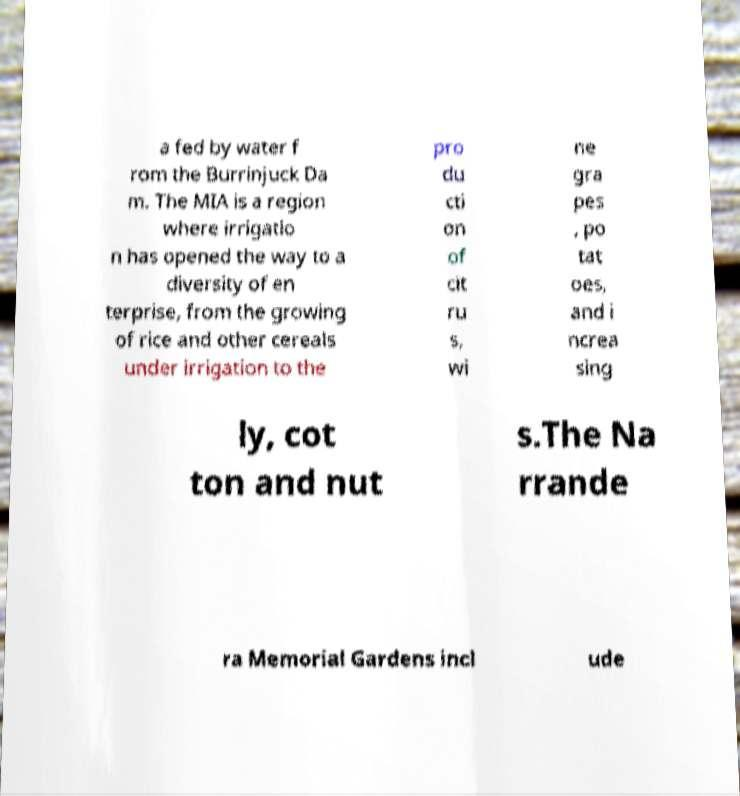For documentation purposes, I need the text within this image transcribed. Could you provide that? a fed by water f rom the Burrinjuck Da m. The MIA is a region where irrigatio n has opened the way to a diversity of en terprise, from the growing of rice and other cereals under irrigation to the pro du cti on of cit ru s, wi ne gra pes , po tat oes, and i ncrea sing ly, cot ton and nut s.The Na rrande ra Memorial Gardens incl ude 